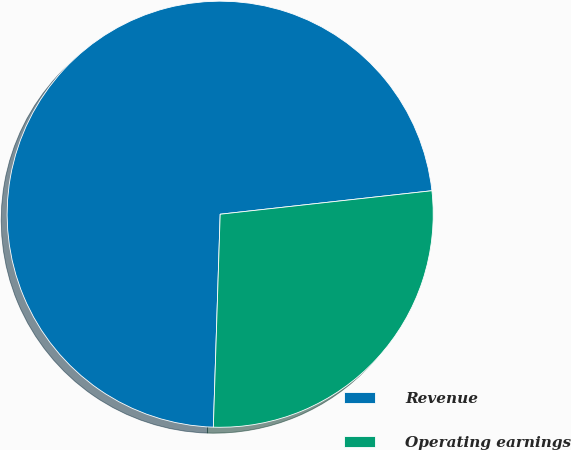Convert chart. <chart><loc_0><loc_0><loc_500><loc_500><pie_chart><fcel>Revenue<fcel>Operating earnings<nl><fcel>72.73%<fcel>27.27%<nl></chart> 